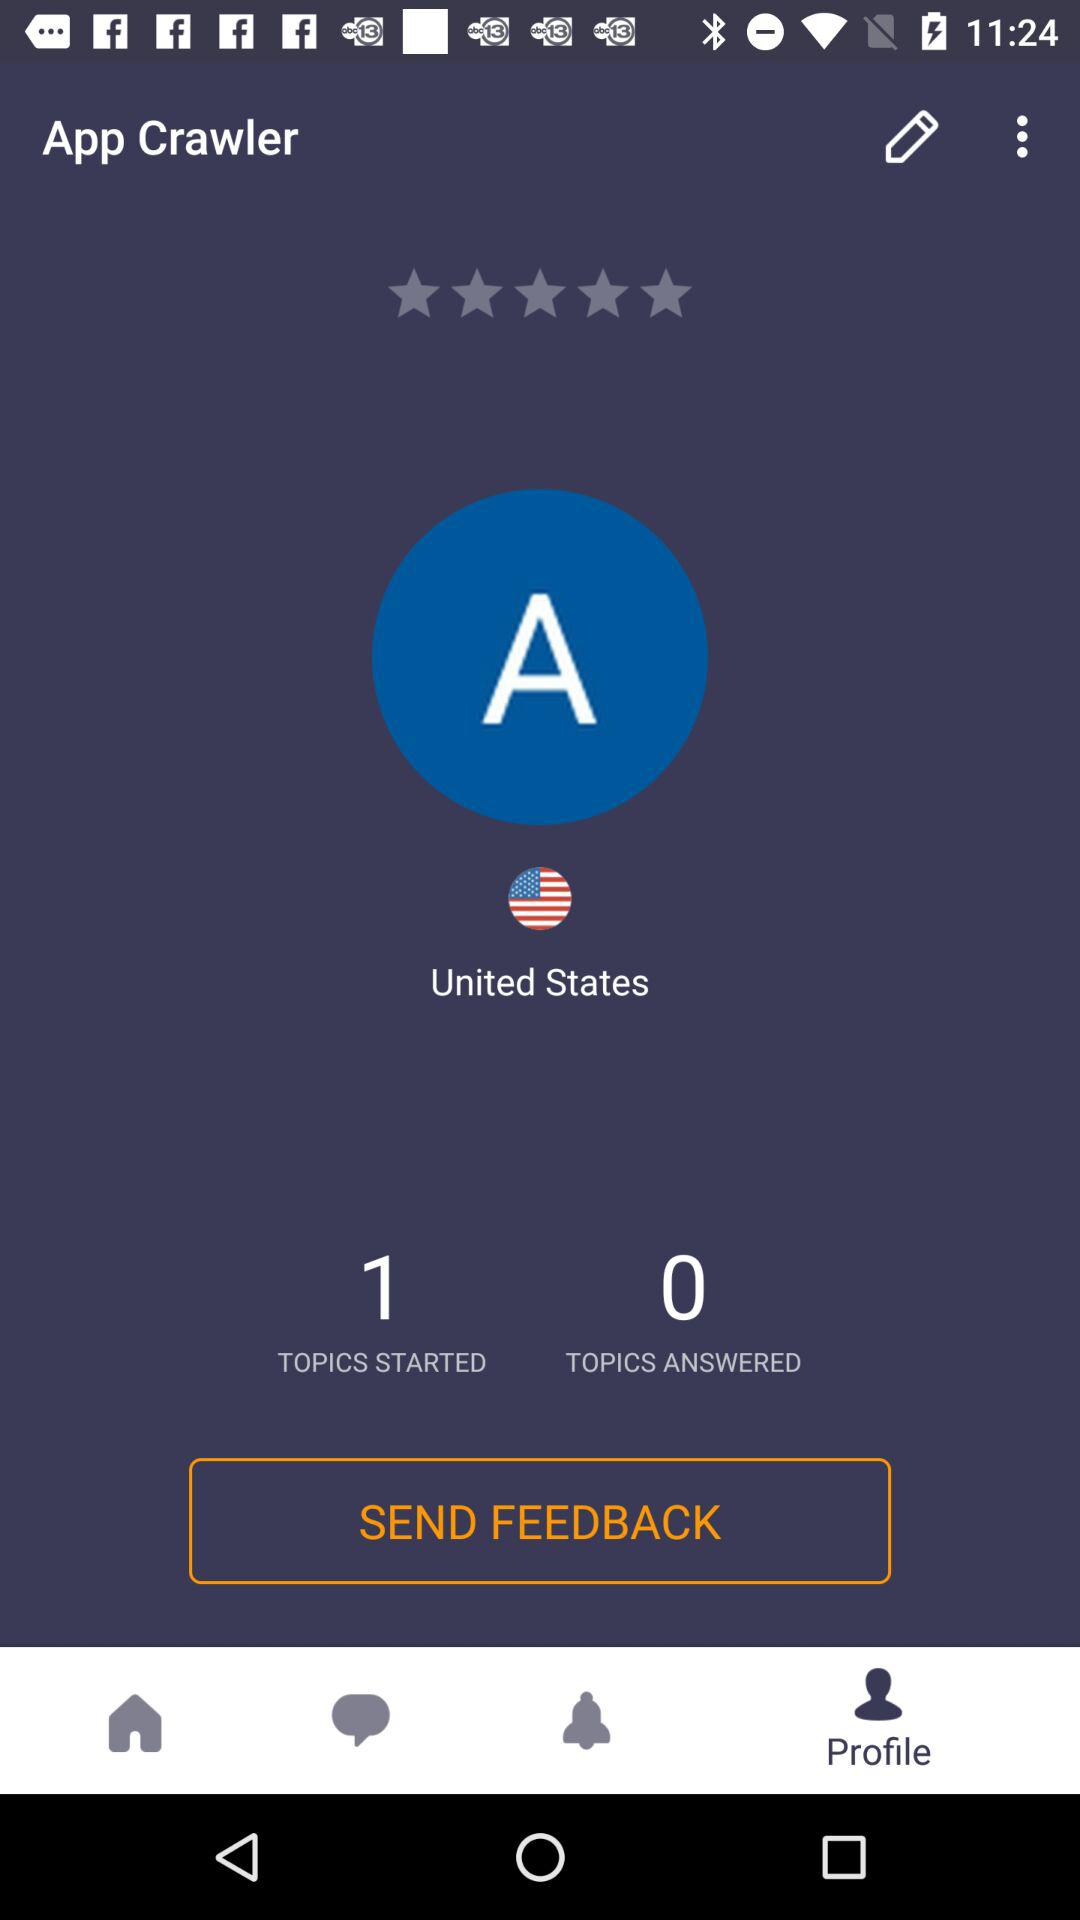How many topics have started? The topic that has been started is 1. 